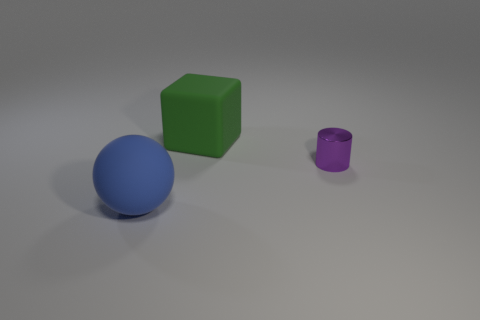Add 1 tiny green rubber objects. How many objects exist? 4 Subtract all rubber balls. Subtract all metallic objects. How many objects are left? 1 Add 1 metallic cylinders. How many metallic cylinders are left? 2 Add 3 balls. How many balls exist? 4 Subtract 0 blue cylinders. How many objects are left? 3 Subtract all cylinders. How many objects are left? 2 Subtract all yellow cylinders. Subtract all yellow blocks. How many cylinders are left? 1 